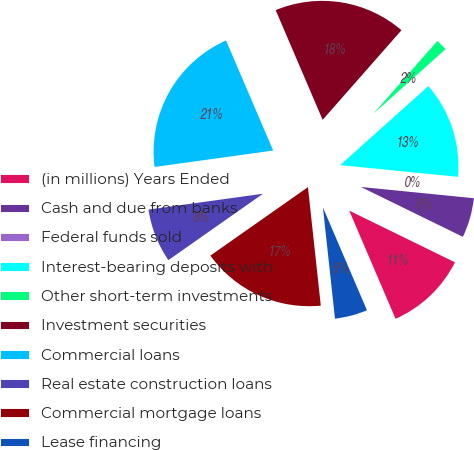Convert chart. <chart><loc_0><loc_0><loc_500><loc_500><pie_chart><fcel>(in millions) Years Ended<fcel>Cash and due from banks<fcel>Federal funds sold<fcel>Interest-bearing deposits with<fcel>Other short-term investments<fcel>Investment securities<fcel>Commercial loans<fcel>Real estate construction loans<fcel>Commercial mortgage loans<fcel>Lease financing<nl><fcel>11.32%<fcel>5.66%<fcel>0.0%<fcel>13.21%<fcel>1.89%<fcel>17.92%<fcel>20.75%<fcel>7.55%<fcel>16.98%<fcel>4.72%<nl></chart> 